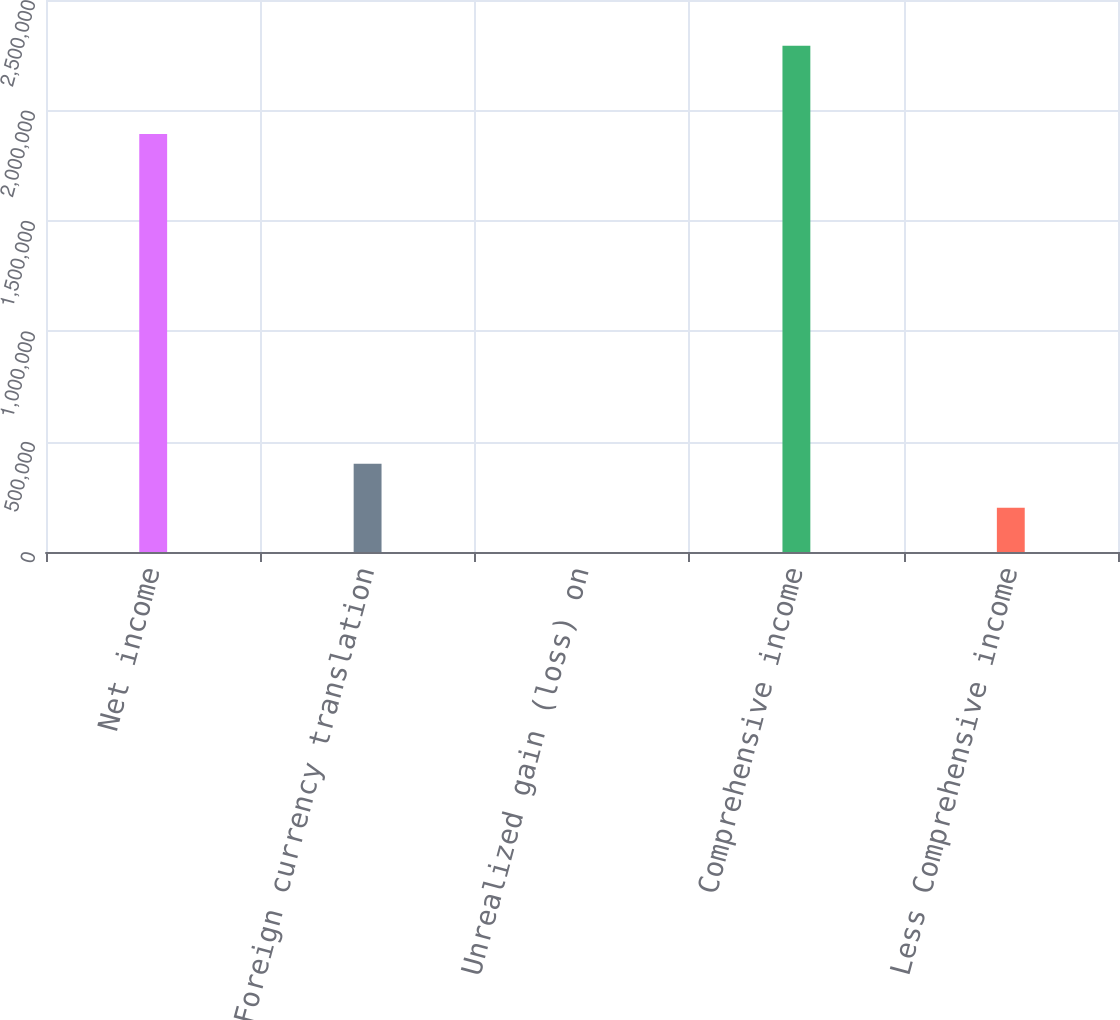<chart> <loc_0><loc_0><loc_500><loc_500><bar_chart><fcel>Net income<fcel>Foreign currency translation<fcel>Unrealized gain (loss) on<fcel>Comprehensive income<fcel>Less Comprehensive income<nl><fcel>1.8928e+06<fcel>400230<fcel>21<fcel>2.29301e+06<fcel>200126<nl></chart> 